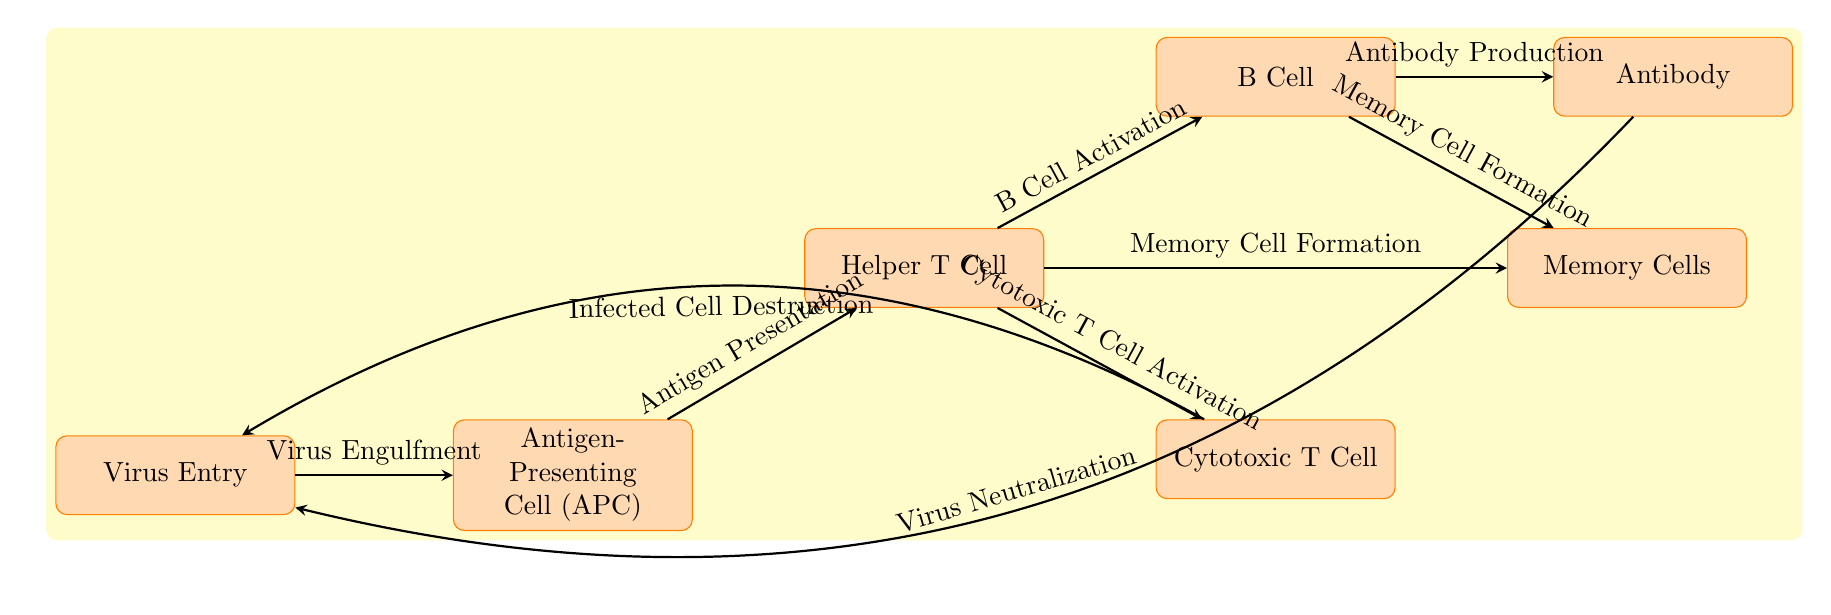What is the first step in the immunological response according to the diagram? The first step in the immunological response as shown in the diagram is "Virus Entry," which is indicated as the initial node where the process begins.
Answer: Virus Entry How many main cells are involved in the immune response depicted in the diagram? The diagram shows five main types of cells involved in the immune response: Virus, APC (Antigen-Presenting Cell), Helper T Cell, Cytotoxic T Cell, and B Cell.
Answer: Five What process follows the activation of Helper T Cells? After the activation of Helper T Cells, the processes that follow are "B Cell Activation" and "Cytotoxic T Cell Activation," which are shown as direct outputs from the Helper T Cell node.
Answer: B Cell Activation and Cytotoxic T Cell Activation Which node is responsible for producing antibodies? The B Cell node is responsible for producing antibodies, as indicated by the arrow leading from B Cell to the Antibody node, labeled "Antibody Production."
Answer: B Cell What happens to the virus as a result of antibody activity? The diagram shows that as a result of antibody activity, the virus undergoes "Virus Neutralization," which is indicated by an arrow from the Antibody node back to the Virus node.
Answer: Virus Neutralization What is formed as a result of Helper T Cell activation? Helper T Cell activation leads to "Memory Cell Formation," as indicated by the arrow from the Helper T Cell node pointing towards the Memory Cells node.
Answer: Memory Cell Formation What action do Cytotoxic T Cells take according to the diagram? Cytotoxic T Cells perform the action of "Infected Cell Destruction," which is indicated by an arrow going from Cytotoxic T Cell to the Virus node.
Answer: Infected Cell Destruction How does the Virus Entry node connect to the Antigen-Presenting Cell? The connection between the Virus Entry node and the Antigen-Presenting Cell is illustrated by the flow of an arrow labeled "Virus Engulfment," indicating the process of the APC engulfing the virus upon entry.
Answer: Virus Engulfment Which node is positioned above the Antibody node? The node positioned above the Antibody node in the diagram is the B Cell, which signifies that B Cells produce antibodies as indicated by their connection with the Antibody node.
Answer: B Cell 